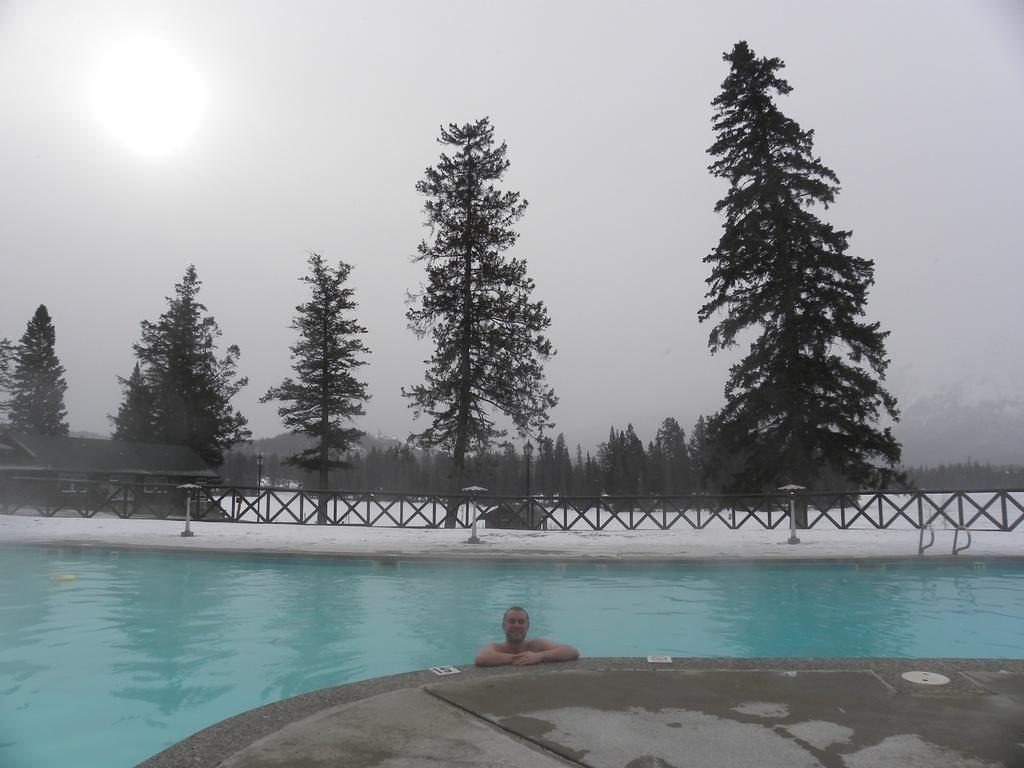What is the main subject in the foreground of the image? There is a man in a swimming pool in the foreground of the image. What type of surface is visible in the foreground of the image? There is floor visible in the foreground of the image. What can be seen in the background of the image? There are poles, railing, trees, and a house in the background of the image. What is the condition of the sky in the image? The sun is visible at the top of the image, indicating clear weather. What type of fear does the man in the swimming pool have in the image? There is no indication of fear in the image; the man appears to be swimming. Can you tell me how many tramps are visible in the image? There are no tramps present in the image. 